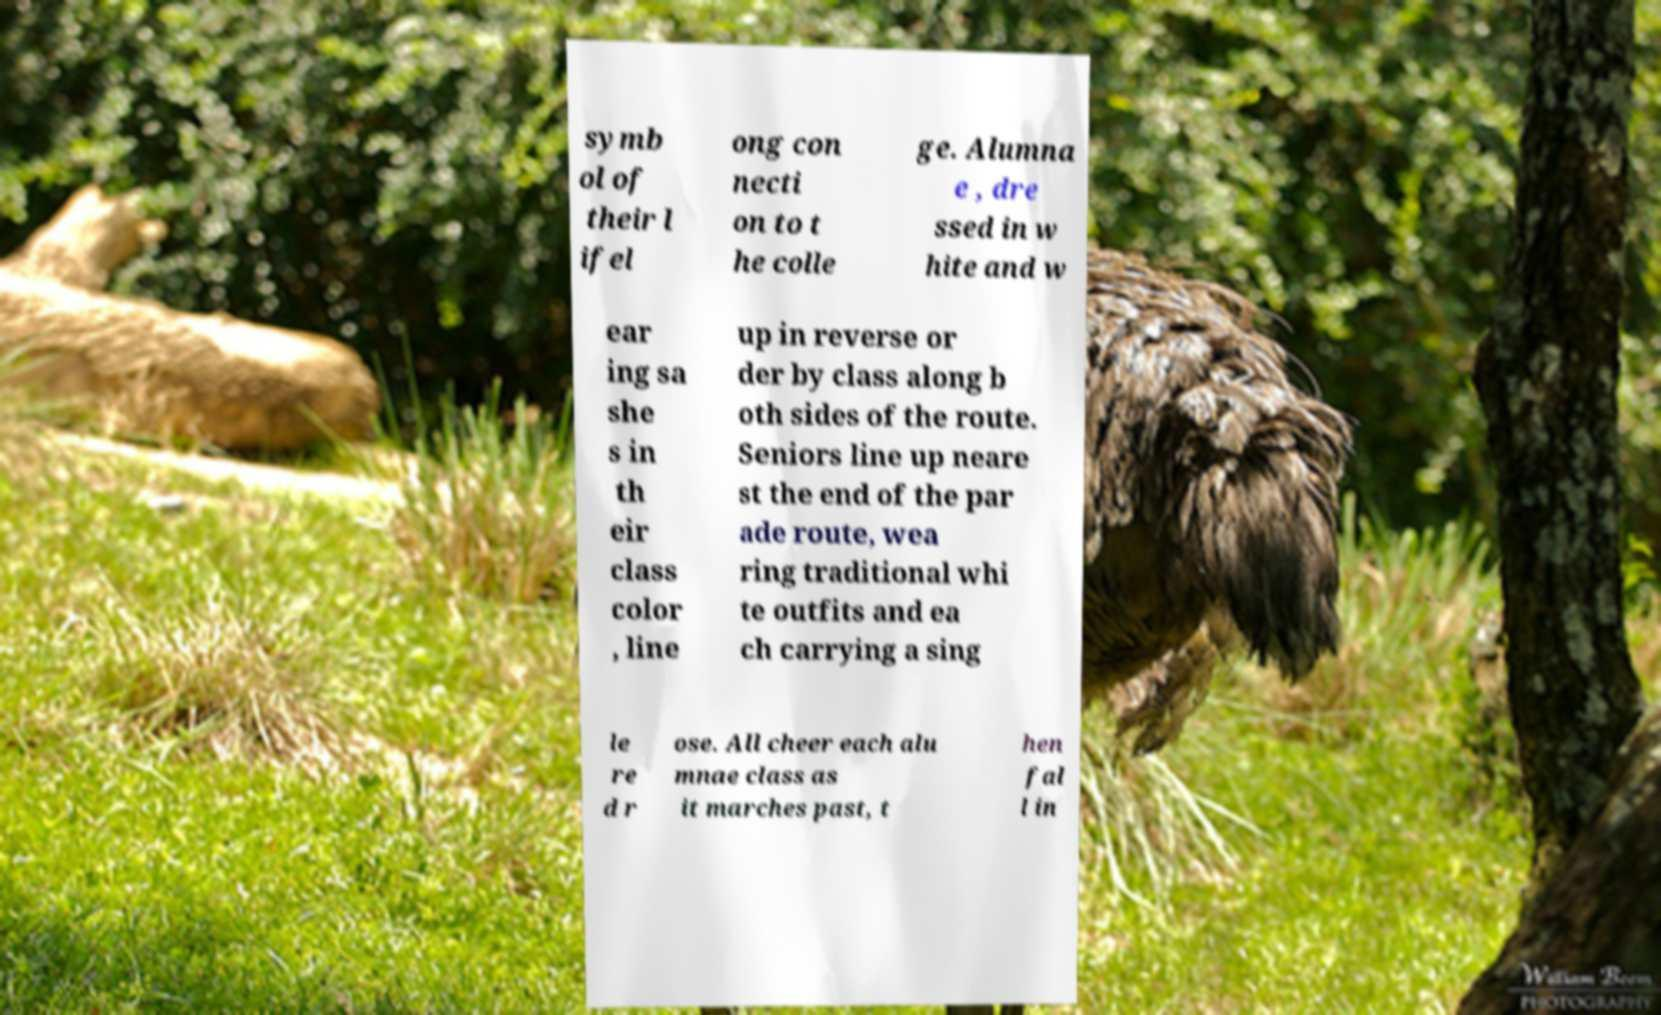What messages or text are displayed in this image? I need them in a readable, typed format. symb ol of their l ifel ong con necti on to t he colle ge. Alumna e , dre ssed in w hite and w ear ing sa she s in th eir class color , line up in reverse or der by class along b oth sides of the route. Seniors line up neare st the end of the par ade route, wea ring traditional whi te outfits and ea ch carrying a sing le re d r ose. All cheer each alu mnae class as it marches past, t hen fal l in 